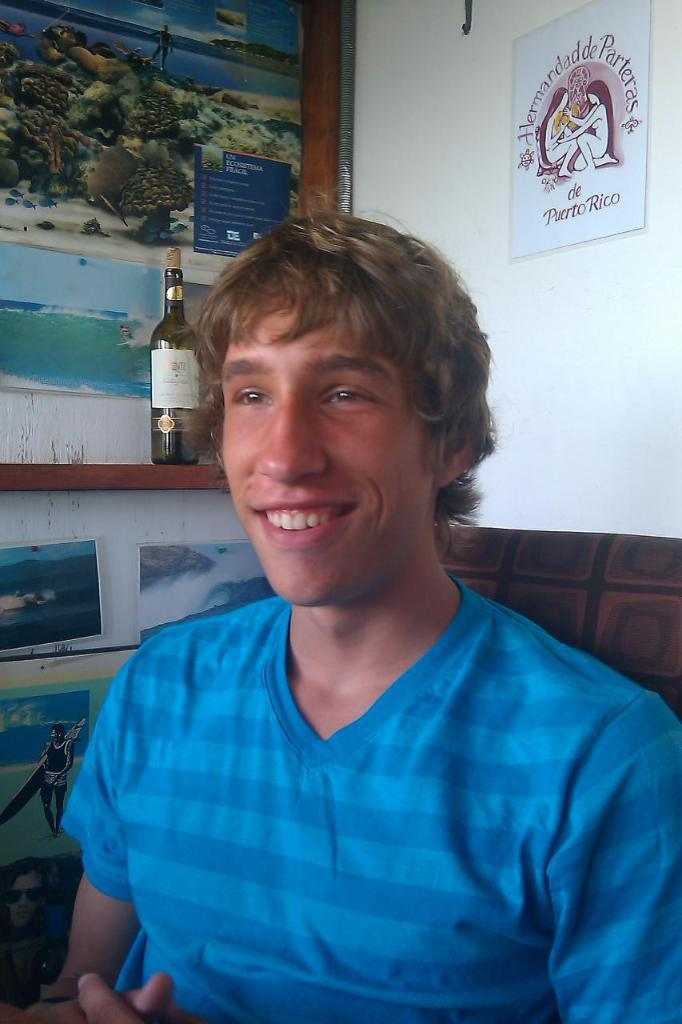What is the person in the image doing? There is a person sitting on a chair in the image. What can be seen on the wall in the image? There are many photos and a few posters on the wall in the image. What is the current hour according to the clock in the image? There is no clock present in the image, so it is not possible to determine the current hour. 